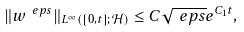<formula> <loc_0><loc_0><loc_500><loc_500>\| w ^ { \ e p s } \| _ { L ^ { \infty } ( [ 0 , t ] ; \mathcal { H } ) } \leq C \sqrt { \ e p s } e ^ { C _ { 1 } t } ,</formula> 